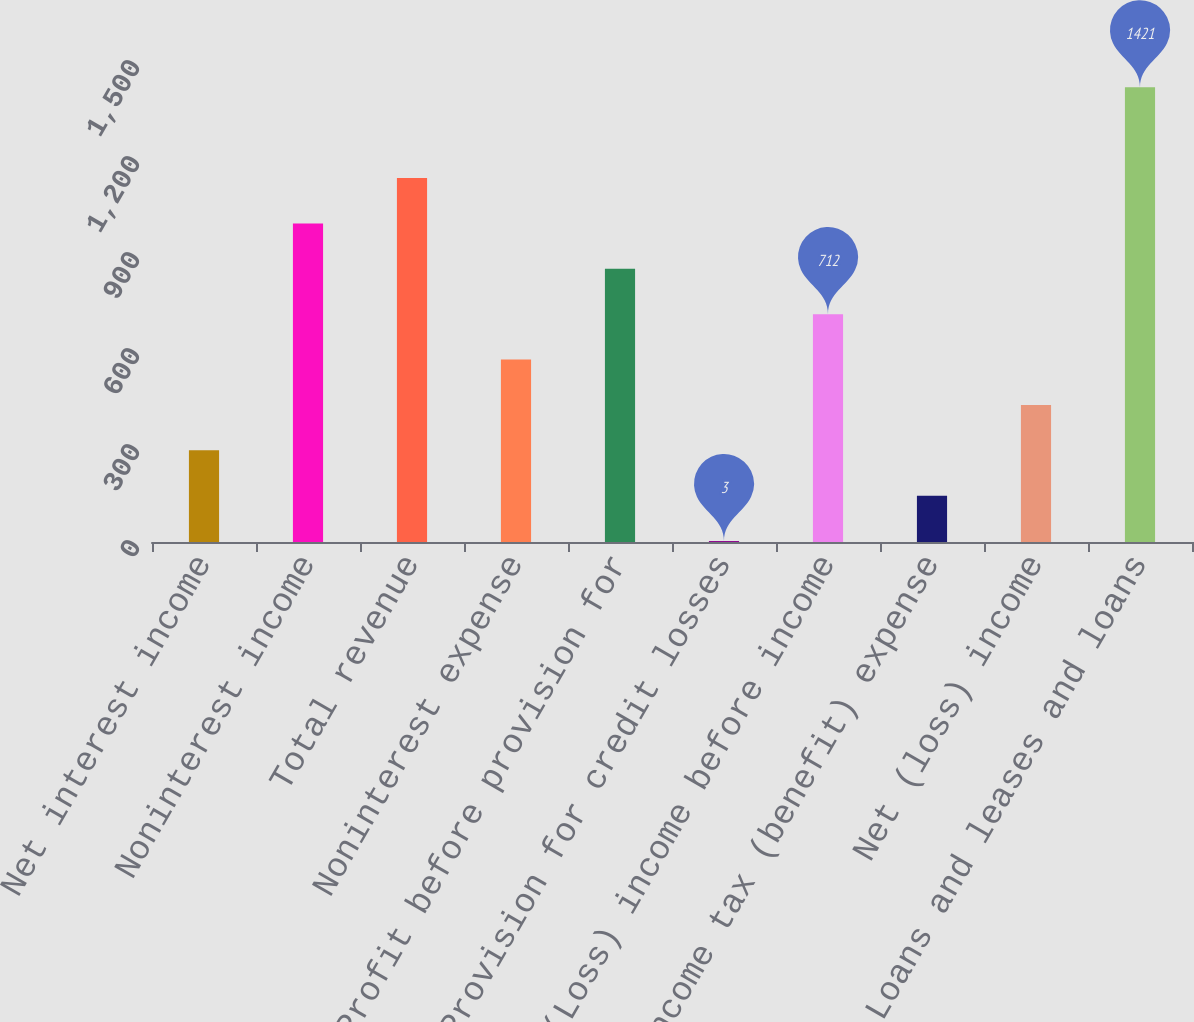Convert chart. <chart><loc_0><loc_0><loc_500><loc_500><bar_chart><fcel>Net interest income<fcel>Noninterest income<fcel>Total revenue<fcel>Noninterest expense<fcel>Profit before provision for<fcel>Provision for credit losses<fcel>(Loss) income before income<fcel>Income tax (benefit) expense<fcel>Net (loss) income<fcel>Loans and leases and loans<nl><fcel>286.6<fcel>995.6<fcel>1137.4<fcel>570.2<fcel>853.8<fcel>3<fcel>712<fcel>144.8<fcel>428.4<fcel>1421<nl></chart> 